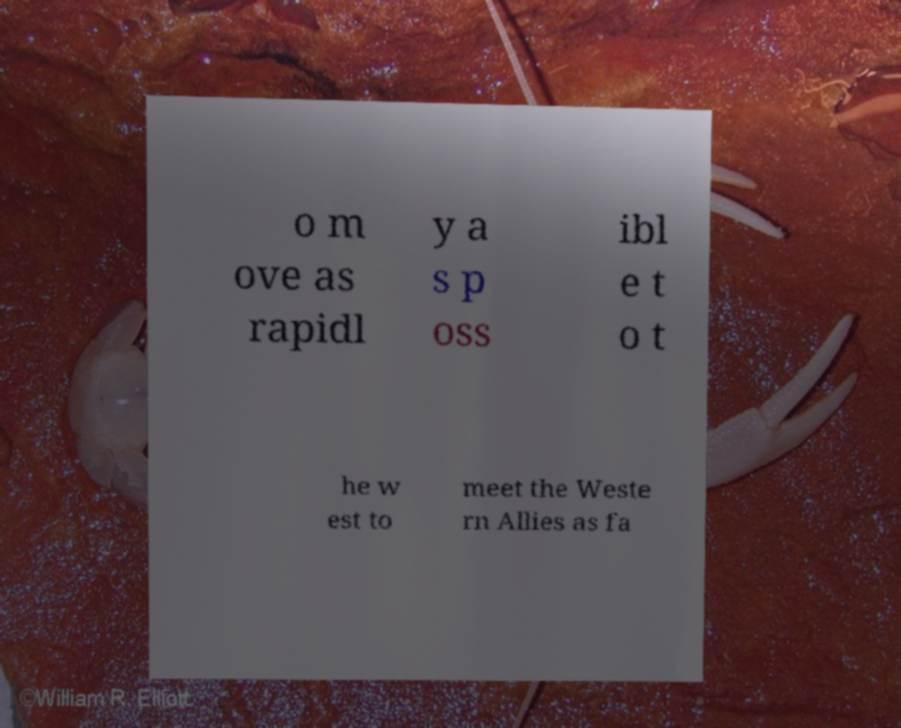Can you accurately transcribe the text from the provided image for me? o m ove as rapidl y a s p oss ibl e t o t he w est to meet the Weste rn Allies as fa 